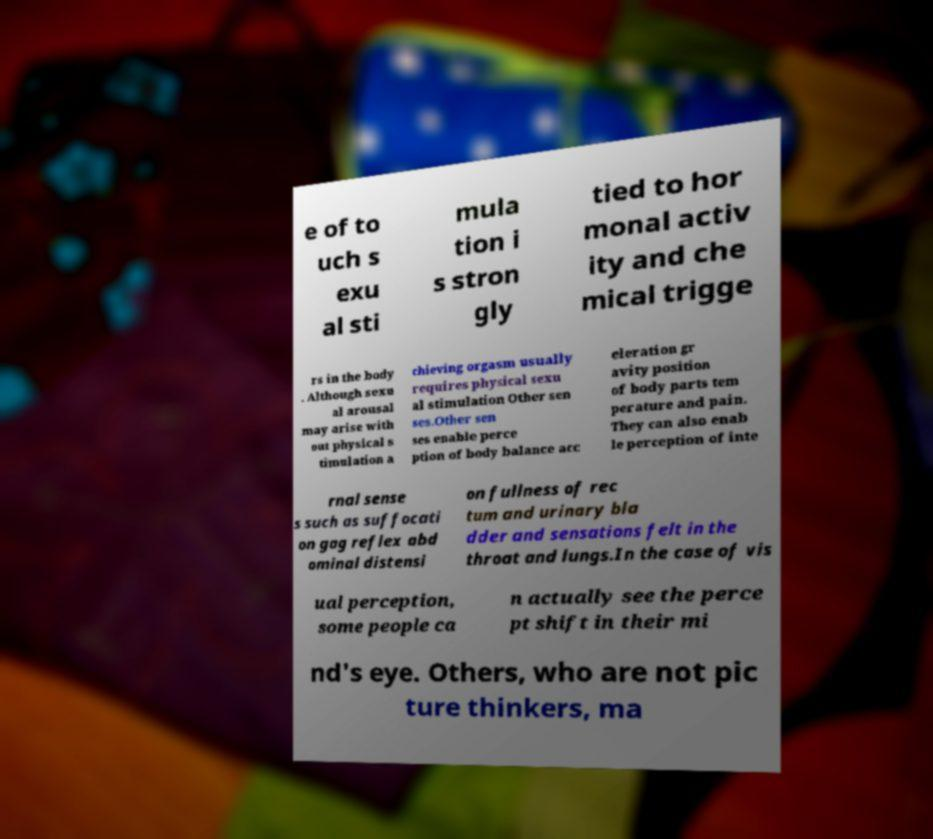Can you read and provide the text displayed in the image?This photo seems to have some interesting text. Can you extract and type it out for me? e of to uch s exu al sti mula tion i s stron gly tied to hor monal activ ity and che mical trigge rs in the body . Although sexu al arousal may arise with out physical s timulation a chieving orgasm usually requires physical sexu al stimulation Other sen ses.Other sen ses enable perce ption of body balance acc eleration gr avity position of body parts tem perature and pain. They can also enab le perception of inte rnal sense s such as suffocati on gag reflex abd ominal distensi on fullness of rec tum and urinary bla dder and sensations felt in the throat and lungs.In the case of vis ual perception, some people ca n actually see the perce pt shift in their mi nd's eye. Others, who are not pic ture thinkers, ma 